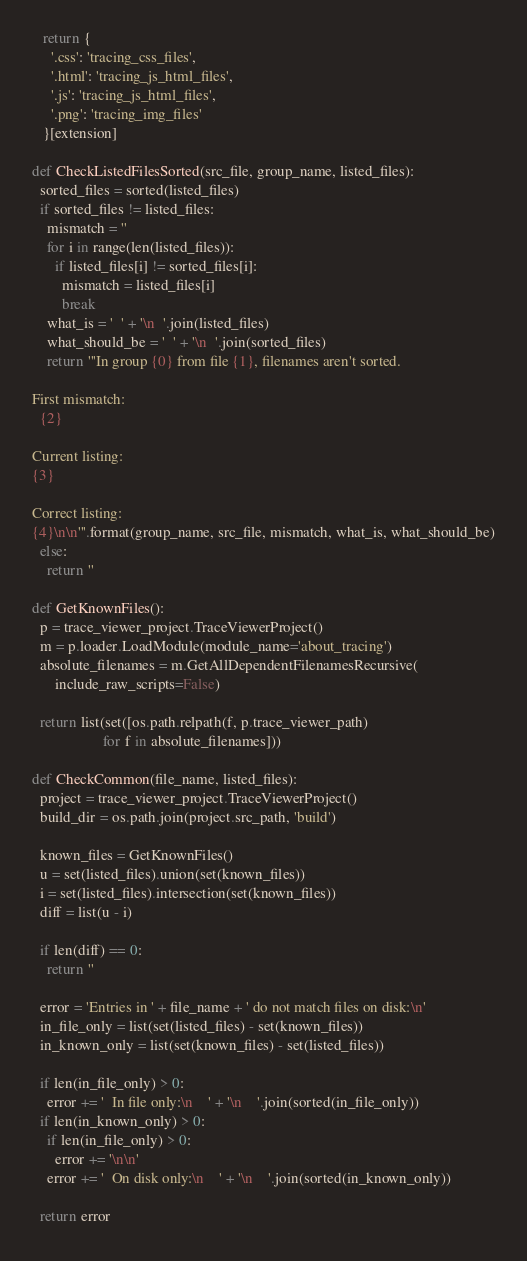Convert code to text. <code><loc_0><loc_0><loc_500><loc_500><_Python_>   return {
     '.css': 'tracing_css_files',
     '.html': 'tracing_js_html_files',
     '.js': 'tracing_js_html_files',
     '.png': 'tracing_img_files'
   }[extension]

def CheckListedFilesSorted(src_file, group_name, listed_files):
  sorted_files = sorted(listed_files)
  if sorted_files != listed_files:
    mismatch = ''
    for i in range(len(listed_files)):
      if listed_files[i] != sorted_files[i]:
        mismatch = listed_files[i]
        break
    what_is = '  ' + '\n  '.join(listed_files)
    what_should_be = '  ' + '\n  '.join(sorted_files)
    return '''In group {0} from file {1}, filenames aren't sorted.

First mismatch:
  {2}

Current listing:
{3}

Correct listing:
{4}\n\n'''.format(group_name, src_file, mismatch, what_is, what_should_be)
  else:
    return ''

def GetKnownFiles():
  p = trace_viewer_project.TraceViewerProject()
  m = p.loader.LoadModule(module_name='about_tracing')
  absolute_filenames = m.GetAllDependentFilenamesRecursive(
      include_raw_scripts=False)

  return list(set([os.path.relpath(f, p.trace_viewer_path)
                   for f in absolute_filenames]))

def CheckCommon(file_name, listed_files):
  project = trace_viewer_project.TraceViewerProject()
  build_dir = os.path.join(project.src_path, 'build')

  known_files = GetKnownFiles()
  u = set(listed_files).union(set(known_files))
  i = set(listed_files).intersection(set(known_files))
  diff = list(u - i)

  if len(diff) == 0:
    return ''

  error = 'Entries in ' + file_name + ' do not match files on disk:\n'
  in_file_only = list(set(listed_files) - set(known_files))
  in_known_only = list(set(known_files) - set(listed_files))

  if len(in_file_only) > 0:
    error += '  In file only:\n    ' + '\n    '.join(sorted(in_file_only))
  if len(in_known_only) > 0:
    if len(in_file_only) > 0:
      error += '\n\n'
    error += '  On disk only:\n    ' + '\n    '.join(sorted(in_known_only))

  return error
</code> 